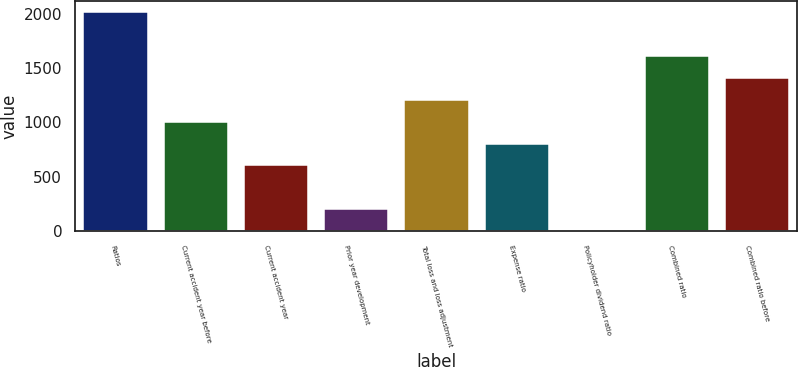<chart> <loc_0><loc_0><loc_500><loc_500><bar_chart><fcel>Ratios<fcel>Current accident year before<fcel>Current accident year<fcel>Prior year development<fcel>Total loss and loss adjustment<fcel>Expense ratio<fcel>Policyholder dividend ratio<fcel>Combined ratio<fcel>Combined ratio before<nl><fcel>2013<fcel>1006.65<fcel>604.11<fcel>201.57<fcel>1207.92<fcel>805.38<fcel>0.3<fcel>1610.46<fcel>1409.19<nl></chart> 